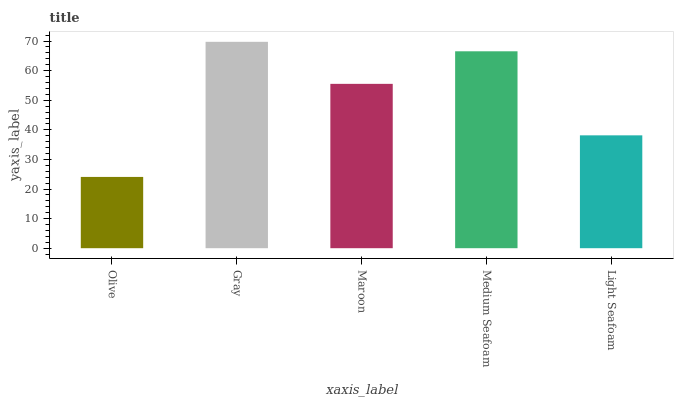Is Olive the minimum?
Answer yes or no. Yes. Is Gray the maximum?
Answer yes or no. Yes. Is Maroon the minimum?
Answer yes or no. No. Is Maroon the maximum?
Answer yes or no. No. Is Gray greater than Maroon?
Answer yes or no. Yes. Is Maroon less than Gray?
Answer yes or no. Yes. Is Maroon greater than Gray?
Answer yes or no. No. Is Gray less than Maroon?
Answer yes or no. No. Is Maroon the high median?
Answer yes or no. Yes. Is Maroon the low median?
Answer yes or no. Yes. Is Light Seafoam the high median?
Answer yes or no. No. Is Light Seafoam the low median?
Answer yes or no. No. 